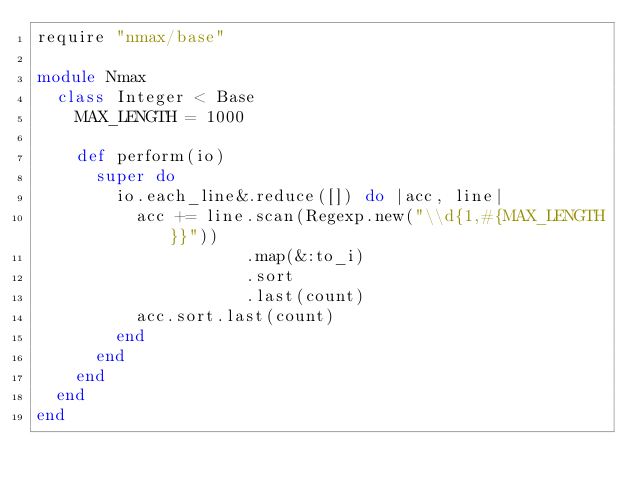Convert code to text. <code><loc_0><loc_0><loc_500><loc_500><_Ruby_>require "nmax/base"

module Nmax
  class Integer < Base
    MAX_LENGTH = 1000

    def perform(io)
      super do
        io.each_line&.reduce([]) do |acc, line|
          acc += line.scan(Regexp.new("\\d{1,#{MAX_LENGTH}}"))
                     .map(&:to_i)
                     .sort
                     .last(count)
          acc.sort.last(count)
        end
      end
    end
  end
end
</code> 